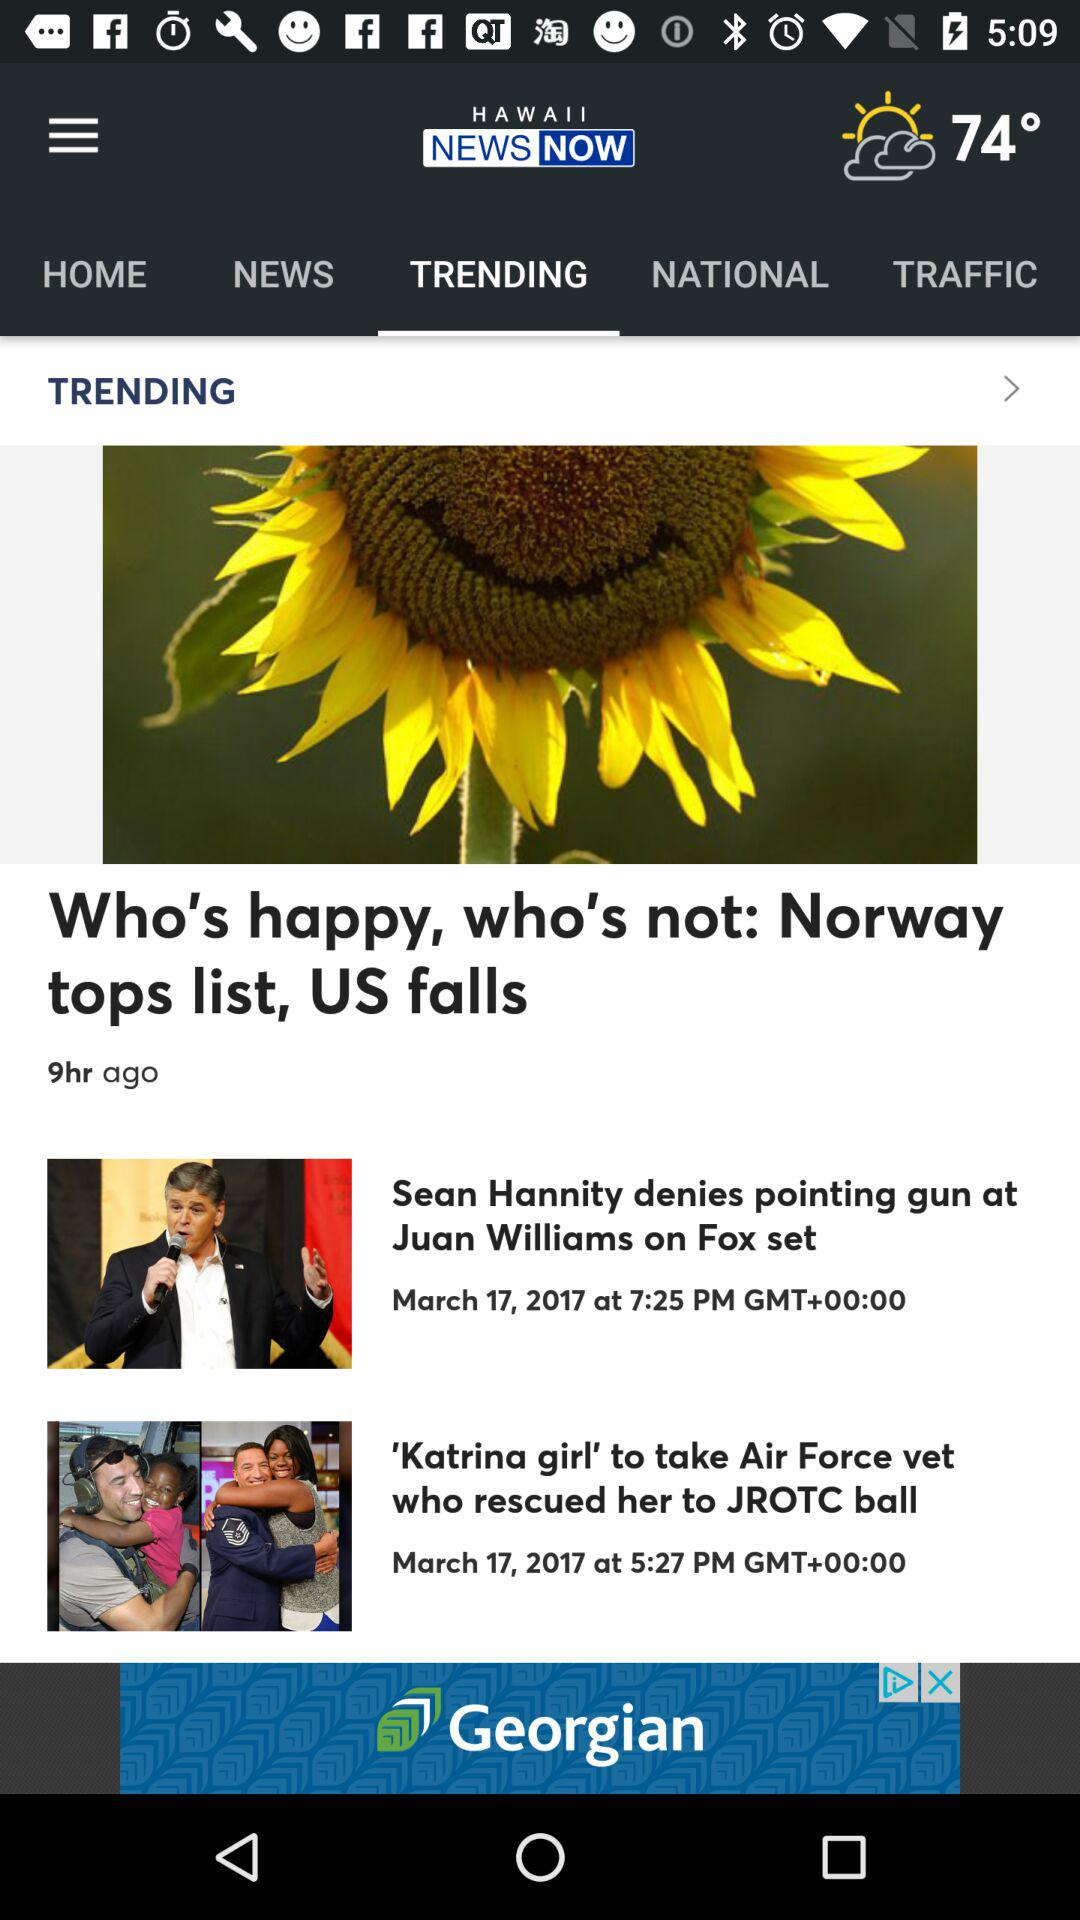What is the date and time of the article "Sean Hannity denies pointing gun at Juan Williams on Fox set"? The date and time of the article "Sean Hannity denies pointing gun at Juan Williams on Fox set" is March 17, 2017 at 7:25 PM. 